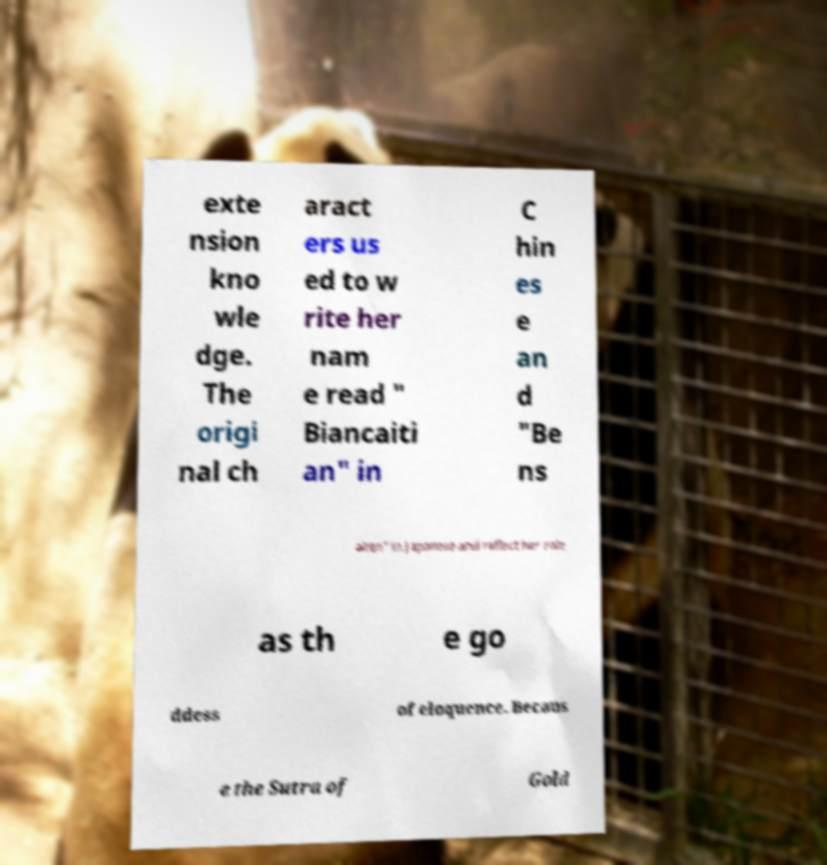Please read and relay the text visible in this image. What does it say? exte nsion kno wle dge. The origi nal ch aract ers us ed to w rite her nam e read " Biancaiti an" in C hin es e an d "Be ns aiten" in Japanese and reflect her role as th e go ddess of eloquence. Becaus e the Sutra of Gold 